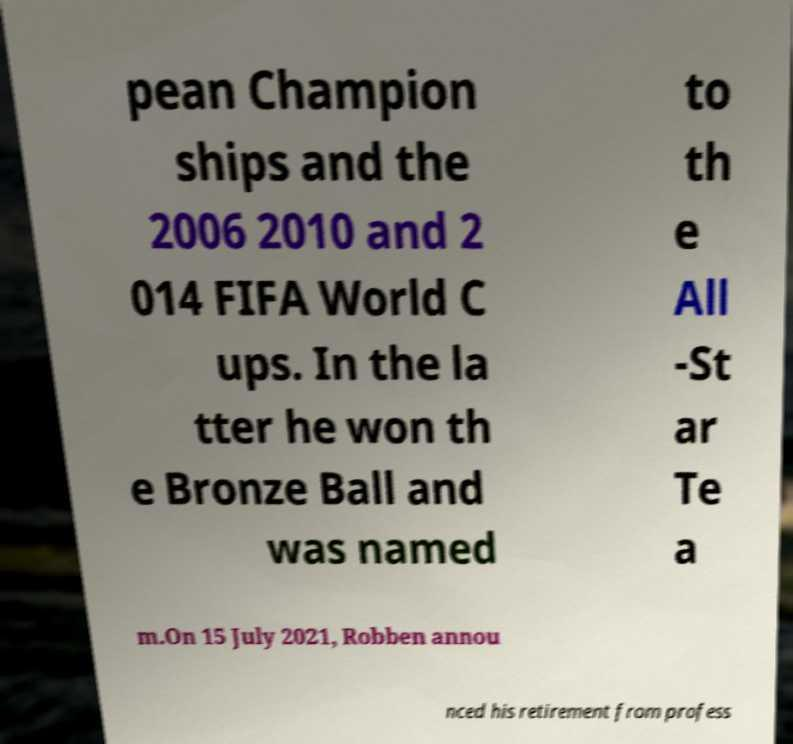Can you accurately transcribe the text from the provided image for me? pean Champion ships and the 2006 2010 and 2 014 FIFA World C ups. In the la tter he won th e Bronze Ball and was named to th e All -St ar Te a m.On 15 July 2021, Robben annou nced his retirement from profess 